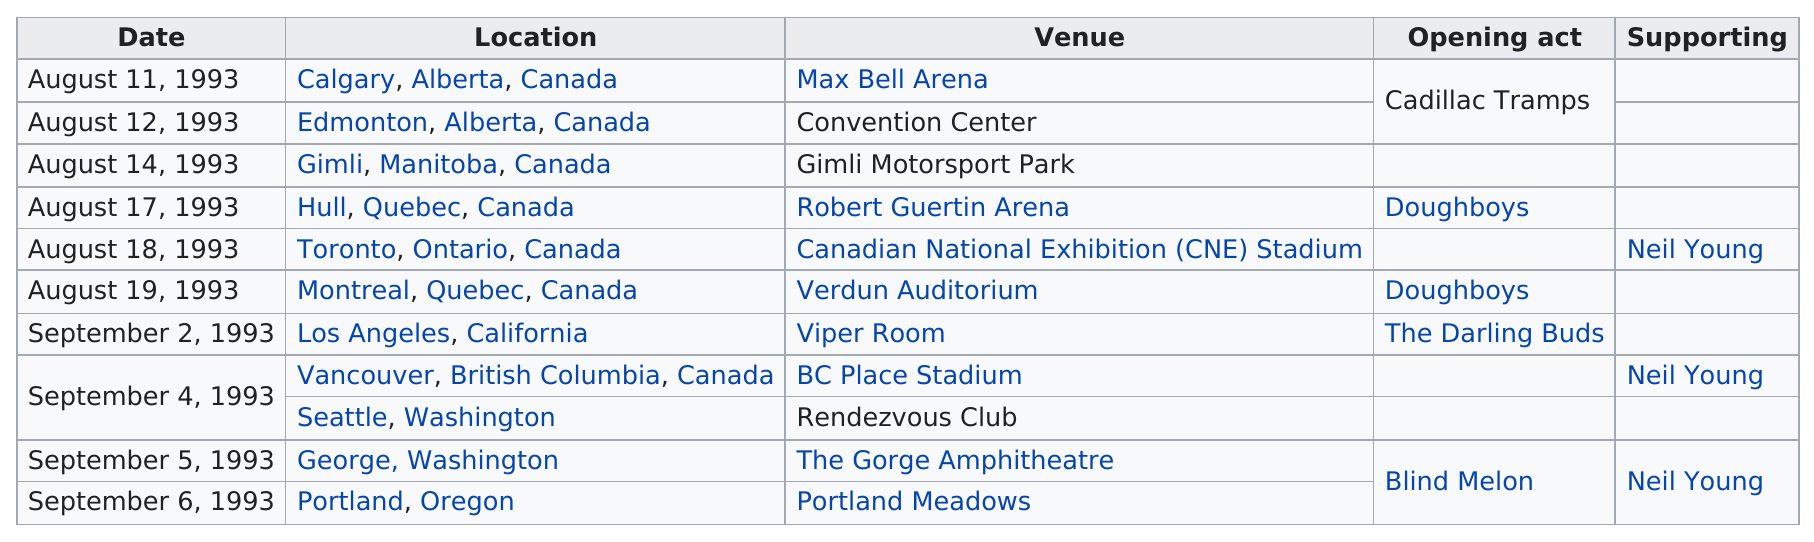Outline some significant characteristics in this image. Pearl Jam had more concerts in the United States than in Canada. The fact that the Calgary or the Toronto leg took place on August 11 remains unclear. The next performance was held at the Viper Room after the one at the Verdun Auditorium. In August of 1993, Pearl Jam performed 6 days in Canada. Alberta is the Canadian province where the most consecutive concerts were played. 